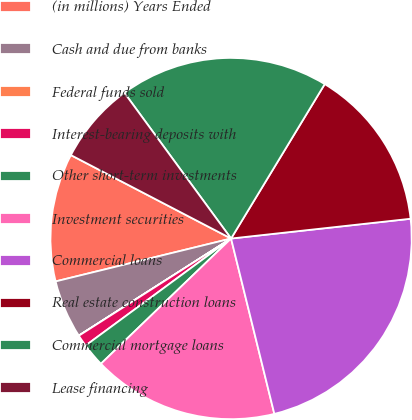<chart> <loc_0><loc_0><loc_500><loc_500><pie_chart><fcel>(in millions) Years Ended<fcel>Cash and due from banks<fcel>Federal funds sold<fcel>Interest-bearing deposits with<fcel>Other short-term investments<fcel>Investment securities<fcel>Commercial loans<fcel>Real estate construction loans<fcel>Commercial mortgage loans<fcel>Lease financing<nl><fcel>11.46%<fcel>5.22%<fcel>0.01%<fcel>1.05%<fcel>2.1%<fcel>16.66%<fcel>22.9%<fcel>14.58%<fcel>18.74%<fcel>7.3%<nl></chart> 